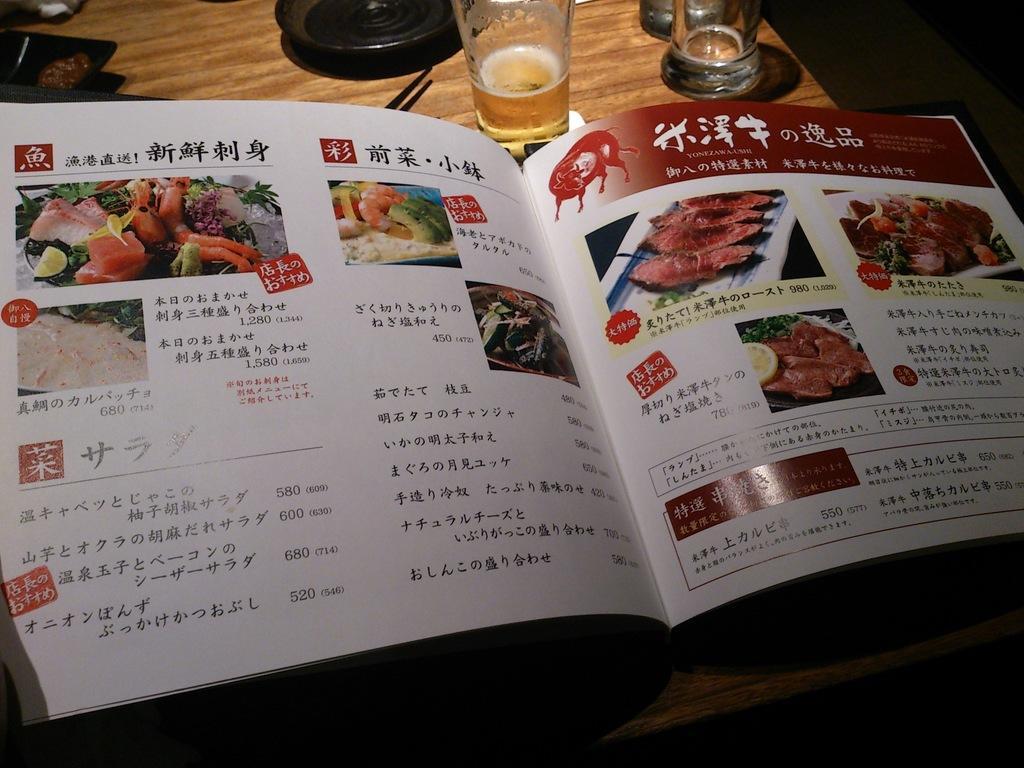Could you give a brief overview of what you see in this image? In the center of the image there is a table. There is a book on the table. There is a glass and there are some other objects on the table. 